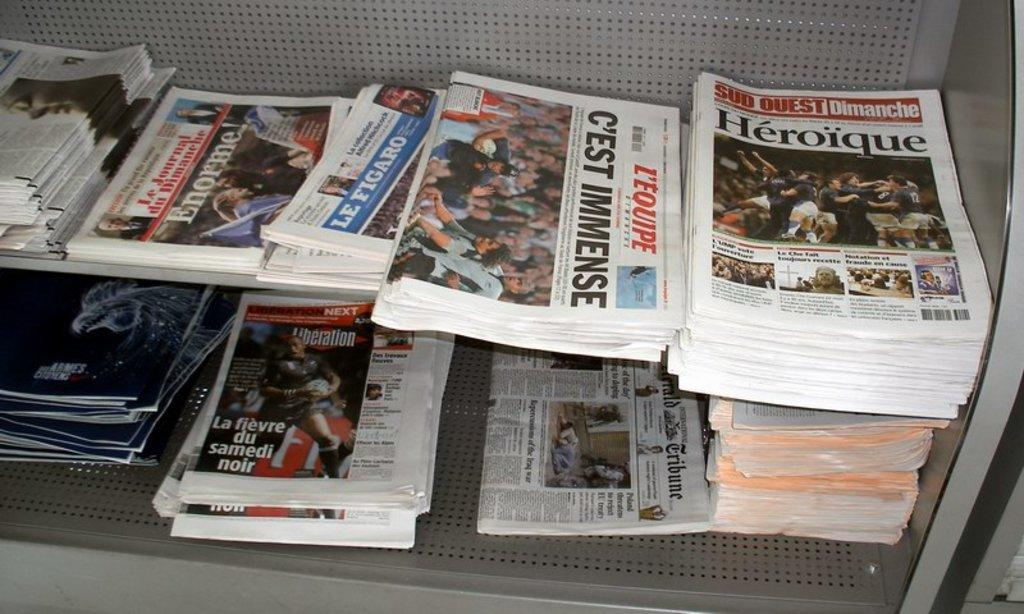<image>
Create a compact narrative representing the image presented. Several newspapers on a shelf discuss the headline "Heroique." 